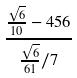Convert formula to latex. <formula><loc_0><loc_0><loc_500><loc_500>\frac { \frac { \sqrt { 6 } } { 1 0 } - 4 5 6 } { \frac { \sqrt { 6 } } { 6 1 } / 7 }</formula> 